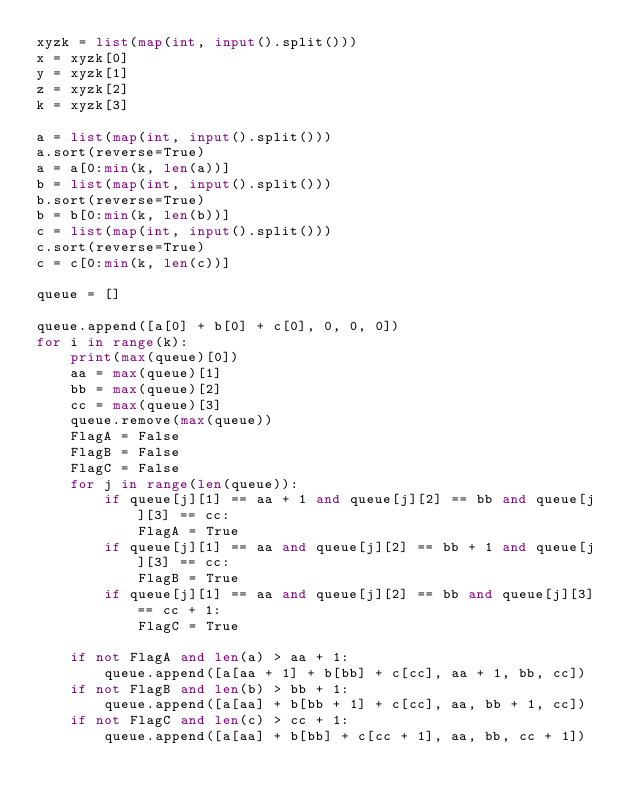<code> <loc_0><loc_0><loc_500><loc_500><_Python_>xyzk = list(map(int, input().split()))
x = xyzk[0]
y = xyzk[1]
z = xyzk[2]
k = xyzk[3]

a = list(map(int, input().split()))
a.sort(reverse=True)
a = a[0:min(k, len(a))]
b = list(map(int, input().split()))
b.sort(reverse=True)
b = b[0:min(k, len(b))]
c = list(map(int, input().split()))
c.sort(reverse=True)
c = c[0:min(k, len(c))]

queue = []

queue.append([a[0] + b[0] + c[0], 0, 0, 0])
for i in range(k):
    print(max(queue)[0])
    aa = max(queue)[1]
    bb = max(queue)[2]
    cc = max(queue)[3]
    queue.remove(max(queue))
    FlagA = False
    FlagB = False
    FlagC = False
    for j in range(len(queue)):
        if queue[j][1] == aa + 1 and queue[j][2] == bb and queue[j][3] == cc:
            FlagA = True
        if queue[j][1] == aa and queue[j][2] == bb + 1 and queue[j][3] == cc:
            FlagB = True
        if queue[j][1] == aa and queue[j][2] == bb and queue[j][3] == cc + 1:
            FlagC = True

    if not FlagA and len(a) > aa + 1:
        queue.append([a[aa + 1] + b[bb] + c[cc], aa + 1, bb, cc])
    if not FlagB and len(b) > bb + 1:
        queue.append([a[aa] + b[bb + 1] + c[cc], aa, bb + 1, cc])
    if not FlagC and len(c) > cc + 1:
        queue.append([a[aa] + b[bb] + c[cc + 1], aa, bb, cc + 1])</code> 